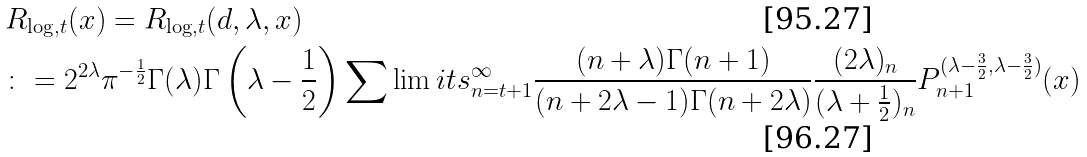<formula> <loc_0><loc_0><loc_500><loc_500>& R _ { \log , t } ( x ) = R _ { \log , t } ( d , \lambda , x ) \\ & \colon = 2 ^ { 2 \lambda } \pi ^ { - \frac { 1 } { 2 } } \Gamma ( \lambda ) \Gamma \left ( \lambda - \frac { 1 } { 2 } \right ) \sum \lim i t s _ { n = t + 1 } ^ { \infty } \frac { ( n + \lambda ) \Gamma ( n + 1 ) } { ( n + 2 \lambda - 1 ) \Gamma ( n + 2 \lambda ) } \frac { ( 2 \lambda ) _ { n } } { ( \lambda + \frac { 1 } { 2 } ) _ { n } } P _ { n + 1 } ^ { ( \lambda - \frac { 3 } { 2 } , \lambda - \frac { 3 } { 2 } ) } ( x )</formula> 